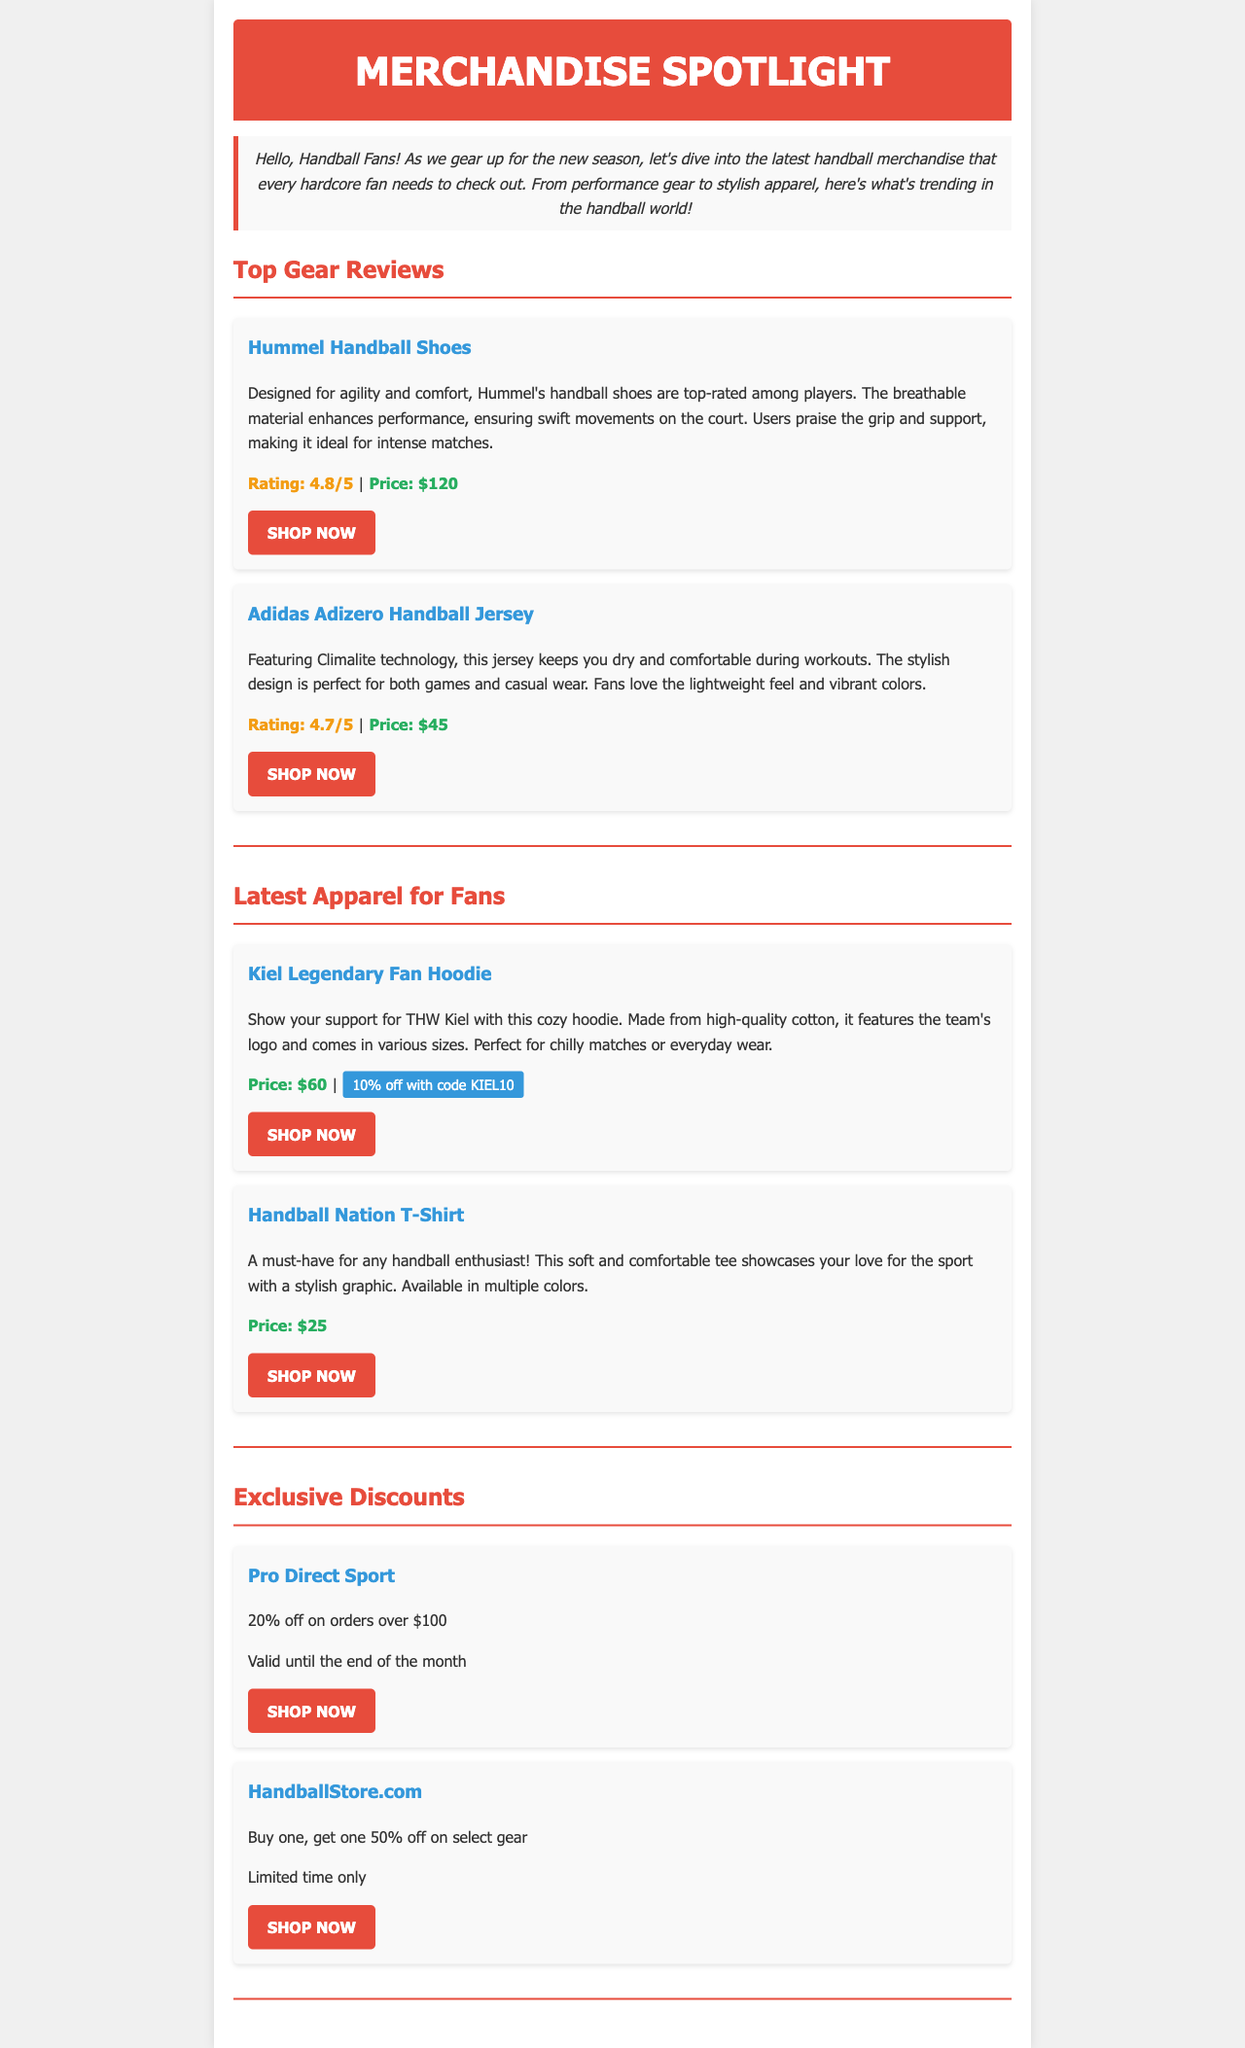What is the price of Hummel Handball Shoes? The price of Hummel Handball Shoes is mentioned directly in the document.
Answer: $120 What type of technology is featured in the Adidas Adizero Handball Jersey? The technology used in the Adidas Adizero Handball Jersey is specified in the description.
Answer: Climalite technology What is the discount code for the Kiel Legendary Fan Hoodie? The discount code for the Kiel Legendary Fan Hoodie is explicitly stated in the document.
Answer: KIEL10 How much discount does Pro Direct Sport offer on orders over $100? The discount percentage for Pro Direct Sport is provided in the exclusive discounts section.
Answer: 20% What is the rating of the Adidas Adizero Handball Jersey? The rating of the Adidas Adizero Handball Jersey is clearly stated in the item description.
Answer: 4.7/5 What is the total price of the Handball Nation T-Shirt? The price of the Handball Nation T-Shirt is mentioned in the document.
Answer: $25 Which fan hoodie is featured in the latest apparel for fans? The specific fan hoodie mentioned in the apparel section is highlighted in the document.
Answer: Kiel Legendary Fan Hoodie What does HandballStore.com offer as a promotion? The promotional offer from HandballStore.com is detailed in the discounts section.
Answer: Buy one, get one 50% off on select gear 